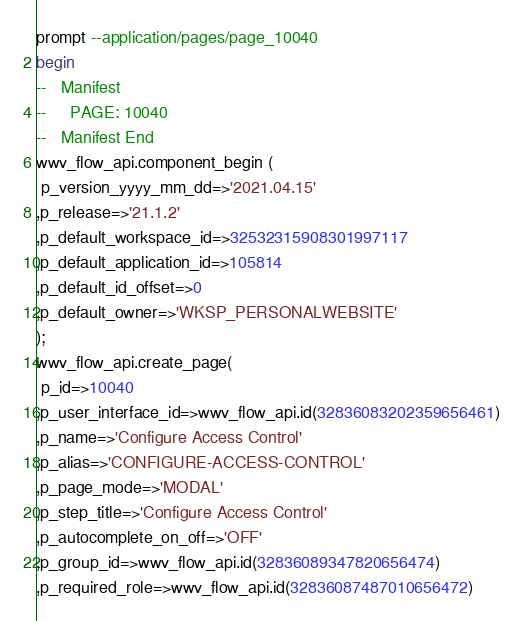Convert code to text. <code><loc_0><loc_0><loc_500><loc_500><_SQL_>prompt --application/pages/page_10040
begin
--   Manifest
--     PAGE: 10040
--   Manifest End
wwv_flow_api.component_begin (
 p_version_yyyy_mm_dd=>'2021.04.15'
,p_release=>'21.1.2'
,p_default_workspace_id=>32532315908301997117
,p_default_application_id=>105814
,p_default_id_offset=>0
,p_default_owner=>'WKSP_PERSONALWEBSITE'
);
wwv_flow_api.create_page(
 p_id=>10040
,p_user_interface_id=>wwv_flow_api.id(32836083202359656461)
,p_name=>'Configure Access Control'
,p_alias=>'CONFIGURE-ACCESS-CONTROL'
,p_page_mode=>'MODAL'
,p_step_title=>'Configure Access Control'
,p_autocomplete_on_off=>'OFF'
,p_group_id=>wwv_flow_api.id(32836089347820656474)
,p_required_role=>wwv_flow_api.id(32836087487010656472)</code> 